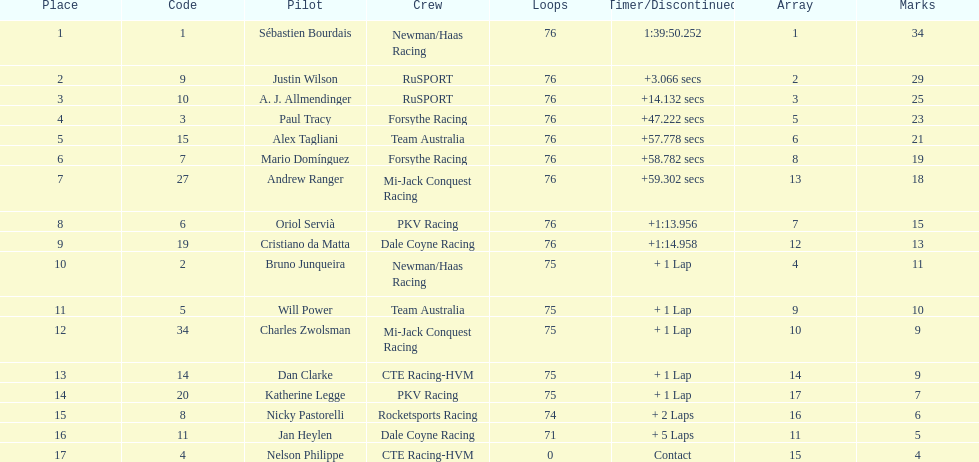What is the total point difference between the driver who received the most points and the driver who received the least? 30. 